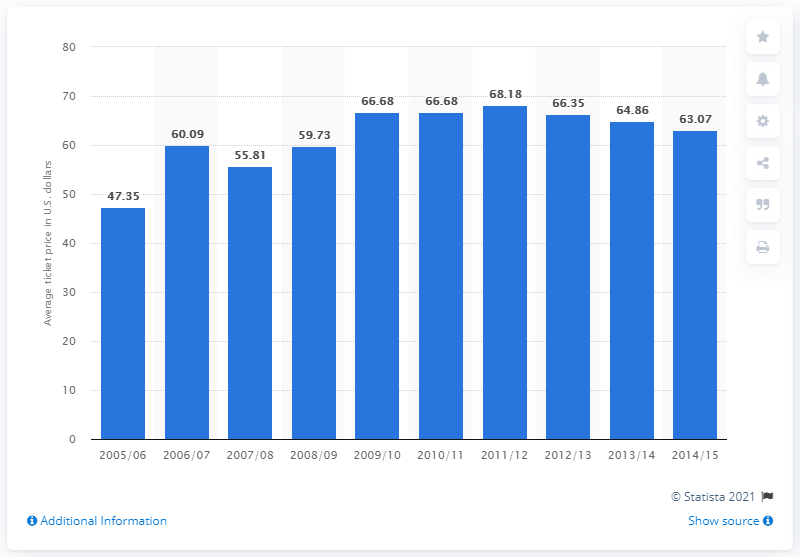Outline some significant characteristics in this image. The average ticket price for Calgary Flames games in the 2005-2006 season was 47.35 dollars. 